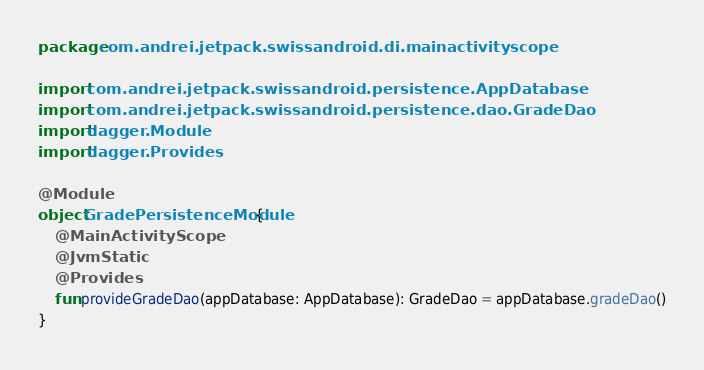Convert code to text. <code><loc_0><loc_0><loc_500><loc_500><_Kotlin_>package com.andrei.jetpack.swissandroid.di.mainactivityscope

import com.andrei.jetpack.swissandroid.persistence.AppDatabase
import com.andrei.jetpack.swissandroid.persistence.dao.GradeDao
import dagger.Module
import dagger.Provides

@Module
object GradePersistenceModule {
    @MainActivityScope
    @JvmStatic
    @Provides
    fun provideGradeDao(appDatabase: AppDatabase): GradeDao = appDatabase.gradeDao()
}</code> 